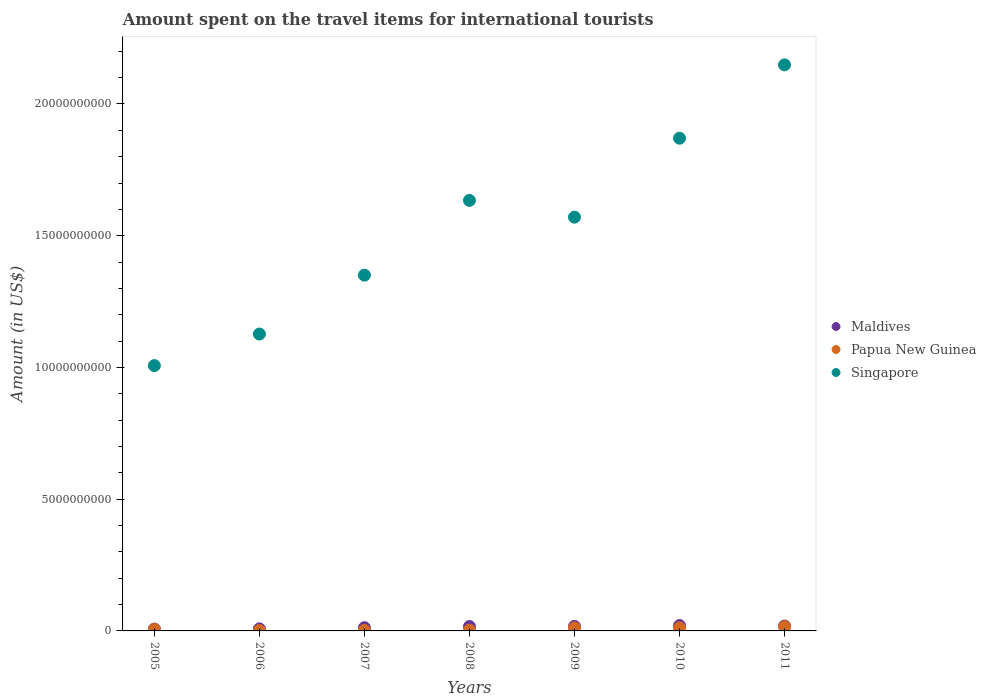How many different coloured dotlines are there?
Provide a succinct answer. 3. What is the amount spent on the travel items for international tourists in Singapore in 2008?
Give a very brief answer. 1.63e+1. Across all years, what is the maximum amount spent on the travel items for international tourists in Singapore?
Keep it short and to the point. 2.15e+1. Across all years, what is the minimum amount spent on the travel items for international tourists in Maldives?
Give a very brief answer. 7.00e+07. In which year was the amount spent on the travel items for international tourists in Singapore maximum?
Provide a short and direct response. 2011. What is the total amount spent on the travel items for international tourists in Singapore in the graph?
Make the answer very short. 1.07e+11. What is the difference between the amount spent on the travel items for international tourists in Papua New Guinea in 2008 and that in 2009?
Provide a short and direct response. -8.40e+07. What is the difference between the amount spent on the travel items for international tourists in Maldives in 2005 and the amount spent on the travel items for international tourists in Singapore in 2008?
Provide a succinct answer. -1.63e+1. What is the average amount spent on the travel items for international tourists in Papua New Guinea per year?
Ensure brevity in your answer.  7.36e+07. In the year 2005, what is the difference between the amount spent on the travel items for international tourists in Singapore and amount spent on the travel items for international tourists in Maldives?
Offer a very short reply. 1.00e+1. What is the ratio of the amount spent on the travel items for international tourists in Singapore in 2008 to that in 2009?
Make the answer very short. 1.04. What is the difference between the highest and the second highest amount spent on the travel items for international tourists in Papua New Guinea?
Offer a very short reply. 4.20e+07. What is the difference between the highest and the lowest amount spent on the travel items for international tourists in Maldives?
Offer a very short reply. 1.35e+08. In how many years, is the amount spent on the travel items for international tourists in Papua New Guinea greater than the average amount spent on the travel items for international tourists in Papua New Guinea taken over all years?
Keep it short and to the point. 3. Is it the case that in every year, the sum of the amount spent on the travel items for international tourists in Singapore and amount spent on the travel items for international tourists in Maldives  is greater than the amount spent on the travel items for international tourists in Papua New Guinea?
Your response must be concise. Yes. How many dotlines are there?
Your answer should be very brief. 3. How many years are there in the graph?
Your response must be concise. 7. What is the difference between two consecutive major ticks on the Y-axis?
Ensure brevity in your answer.  5.00e+09. Does the graph contain any zero values?
Your answer should be very brief. No. How many legend labels are there?
Your answer should be very brief. 3. What is the title of the graph?
Offer a very short reply. Amount spent on the travel items for international tourists. Does "Zimbabwe" appear as one of the legend labels in the graph?
Your response must be concise. No. What is the label or title of the Y-axis?
Your answer should be very brief. Amount (in US$). What is the Amount (in US$) in Maldives in 2005?
Keep it short and to the point. 7.00e+07. What is the Amount (in US$) of Papua New Guinea in 2005?
Give a very brief answer. 5.60e+07. What is the Amount (in US$) of Singapore in 2005?
Offer a very short reply. 1.01e+1. What is the Amount (in US$) in Maldives in 2006?
Provide a succinct answer. 7.80e+07. What is the Amount (in US$) in Papua New Guinea in 2006?
Give a very brief answer. 1.60e+07. What is the Amount (in US$) of Singapore in 2006?
Ensure brevity in your answer.  1.13e+1. What is the Amount (in US$) of Maldives in 2007?
Your response must be concise. 1.22e+08. What is the Amount (in US$) of Papua New Guinea in 2007?
Give a very brief answer. 2.10e+07. What is the Amount (in US$) of Singapore in 2007?
Keep it short and to the point. 1.35e+1. What is the Amount (in US$) of Maldives in 2008?
Provide a succinct answer. 1.67e+08. What is the Amount (in US$) in Papua New Guinea in 2008?
Your response must be concise. 2.90e+07. What is the Amount (in US$) in Singapore in 2008?
Provide a succinct answer. 1.63e+1. What is the Amount (in US$) in Maldives in 2009?
Make the answer very short. 1.74e+08. What is the Amount (in US$) of Papua New Guinea in 2009?
Offer a very short reply. 1.13e+08. What is the Amount (in US$) in Singapore in 2009?
Provide a short and direct response. 1.57e+1. What is the Amount (in US$) of Maldives in 2010?
Ensure brevity in your answer.  2.05e+08. What is the Amount (in US$) in Papua New Guinea in 2010?
Provide a succinct answer. 1.19e+08. What is the Amount (in US$) in Singapore in 2010?
Your answer should be compact. 1.87e+1. What is the Amount (in US$) of Maldives in 2011?
Provide a short and direct response. 1.86e+08. What is the Amount (in US$) in Papua New Guinea in 2011?
Provide a succinct answer. 1.61e+08. What is the Amount (in US$) of Singapore in 2011?
Offer a terse response. 2.15e+1. Across all years, what is the maximum Amount (in US$) of Maldives?
Your response must be concise. 2.05e+08. Across all years, what is the maximum Amount (in US$) in Papua New Guinea?
Your answer should be very brief. 1.61e+08. Across all years, what is the maximum Amount (in US$) of Singapore?
Offer a very short reply. 2.15e+1. Across all years, what is the minimum Amount (in US$) of Maldives?
Your response must be concise. 7.00e+07. Across all years, what is the minimum Amount (in US$) in Papua New Guinea?
Provide a short and direct response. 1.60e+07. Across all years, what is the minimum Amount (in US$) of Singapore?
Your answer should be very brief. 1.01e+1. What is the total Amount (in US$) of Maldives in the graph?
Provide a short and direct response. 1.00e+09. What is the total Amount (in US$) of Papua New Guinea in the graph?
Your response must be concise. 5.15e+08. What is the total Amount (in US$) of Singapore in the graph?
Give a very brief answer. 1.07e+11. What is the difference between the Amount (in US$) in Maldives in 2005 and that in 2006?
Keep it short and to the point. -8.00e+06. What is the difference between the Amount (in US$) in Papua New Guinea in 2005 and that in 2006?
Offer a very short reply. 4.00e+07. What is the difference between the Amount (in US$) of Singapore in 2005 and that in 2006?
Offer a very short reply. -1.20e+09. What is the difference between the Amount (in US$) of Maldives in 2005 and that in 2007?
Make the answer very short. -5.20e+07. What is the difference between the Amount (in US$) of Papua New Guinea in 2005 and that in 2007?
Your response must be concise. 3.50e+07. What is the difference between the Amount (in US$) of Singapore in 2005 and that in 2007?
Your response must be concise. -3.43e+09. What is the difference between the Amount (in US$) of Maldives in 2005 and that in 2008?
Offer a terse response. -9.70e+07. What is the difference between the Amount (in US$) in Papua New Guinea in 2005 and that in 2008?
Provide a short and direct response. 2.70e+07. What is the difference between the Amount (in US$) of Singapore in 2005 and that in 2008?
Ensure brevity in your answer.  -6.27e+09. What is the difference between the Amount (in US$) of Maldives in 2005 and that in 2009?
Offer a very short reply. -1.04e+08. What is the difference between the Amount (in US$) in Papua New Guinea in 2005 and that in 2009?
Ensure brevity in your answer.  -5.70e+07. What is the difference between the Amount (in US$) of Singapore in 2005 and that in 2009?
Your answer should be compact. -5.63e+09. What is the difference between the Amount (in US$) in Maldives in 2005 and that in 2010?
Give a very brief answer. -1.35e+08. What is the difference between the Amount (in US$) of Papua New Guinea in 2005 and that in 2010?
Give a very brief answer. -6.30e+07. What is the difference between the Amount (in US$) of Singapore in 2005 and that in 2010?
Make the answer very short. -8.63e+09. What is the difference between the Amount (in US$) in Maldives in 2005 and that in 2011?
Make the answer very short. -1.16e+08. What is the difference between the Amount (in US$) in Papua New Guinea in 2005 and that in 2011?
Provide a succinct answer. -1.05e+08. What is the difference between the Amount (in US$) of Singapore in 2005 and that in 2011?
Give a very brief answer. -1.14e+1. What is the difference between the Amount (in US$) in Maldives in 2006 and that in 2007?
Give a very brief answer. -4.40e+07. What is the difference between the Amount (in US$) of Papua New Guinea in 2006 and that in 2007?
Provide a short and direct response. -5.00e+06. What is the difference between the Amount (in US$) in Singapore in 2006 and that in 2007?
Provide a short and direct response. -2.24e+09. What is the difference between the Amount (in US$) of Maldives in 2006 and that in 2008?
Offer a terse response. -8.90e+07. What is the difference between the Amount (in US$) of Papua New Guinea in 2006 and that in 2008?
Give a very brief answer. -1.30e+07. What is the difference between the Amount (in US$) in Singapore in 2006 and that in 2008?
Keep it short and to the point. -5.07e+09. What is the difference between the Amount (in US$) in Maldives in 2006 and that in 2009?
Ensure brevity in your answer.  -9.60e+07. What is the difference between the Amount (in US$) in Papua New Guinea in 2006 and that in 2009?
Provide a succinct answer. -9.70e+07. What is the difference between the Amount (in US$) of Singapore in 2006 and that in 2009?
Keep it short and to the point. -4.44e+09. What is the difference between the Amount (in US$) of Maldives in 2006 and that in 2010?
Your answer should be compact. -1.27e+08. What is the difference between the Amount (in US$) in Papua New Guinea in 2006 and that in 2010?
Give a very brief answer. -1.03e+08. What is the difference between the Amount (in US$) of Singapore in 2006 and that in 2010?
Make the answer very short. -7.43e+09. What is the difference between the Amount (in US$) of Maldives in 2006 and that in 2011?
Give a very brief answer. -1.08e+08. What is the difference between the Amount (in US$) of Papua New Guinea in 2006 and that in 2011?
Your answer should be very brief. -1.45e+08. What is the difference between the Amount (in US$) of Singapore in 2006 and that in 2011?
Your response must be concise. -1.02e+1. What is the difference between the Amount (in US$) in Maldives in 2007 and that in 2008?
Give a very brief answer. -4.50e+07. What is the difference between the Amount (in US$) of Papua New Guinea in 2007 and that in 2008?
Your answer should be very brief. -8.00e+06. What is the difference between the Amount (in US$) of Singapore in 2007 and that in 2008?
Provide a succinct answer. -2.84e+09. What is the difference between the Amount (in US$) of Maldives in 2007 and that in 2009?
Offer a very short reply. -5.20e+07. What is the difference between the Amount (in US$) in Papua New Guinea in 2007 and that in 2009?
Give a very brief answer. -9.20e+07. What is the difference between the Amount (in US$) of Singapore in 2007 and that in 2009?
Your answer should be very brief. -2.20e+09. What is the difference between the Amount (in US$) of Maldives in 2007 and that in 2010?
Offer a very short reply. -8.30e+07. What is the difference between the Amount (in US$) in Papua New Guinea in 2007 and that in 2010?
Offer a very short reply. -9.80e+07. What is the difference between the Amount (in US$) in Singapore in 2007 and that in 2010?
Your answer should be compact. -5.20e+09. What is the difference between the Amount (in US$) in Maldives in 2007 and that in 2011?
Your answer should be very brief. -6.40e+07. What is the difference between the Amount (in US$) of Papua New Guinea in 2007 and that in 2011?
Give a very brief answer. -1.40e+08. What is the difference between the Amount (in US$) of Singapore in 2007 and that in 2011?
Offer a very short reply. -7.98e+09. What is the difference between the Amount (in US$) in Maldives in 2008 and that in 2009?
Keep it short and to the point. -7.00e+06. What is the difference between the Amount (in US$) in Papua New Guinea in 2008 and that in 2009?
Offer a very short reply. -8.40e+07. What is the difference between the Amount (in US$) in Singapore in 2008 and that in 2009?
Offer a terse response. 6.36e+08. What is the difference between the Amount (in US$) of Maldives in 2008 and that in 2010?
Make the answer very short. -3.80e+07. What is the difference between the Amount (in US$) in Papua New Guinea in 2008 and that in 2010?
Your answer should be compact. -9.00e+07. What is the difference between the Amount (in US$) in Singapore in 2008 and that in 2010?
Your answer should be compact. -2.36e+09. What is the difference between the Amount (in US$) of Maldives in 2008 and that in 2011?
Your answer should be very brief. -1.90e+07. What is the difference between the Amount (in US$) in Papua New Guinea in 2008 and that in 2011?
Offer a terse response. -1.32e+08. What is the difference between the Amount (in US$) in Singapore in 2008 and that in 2011?
Offer a very short reply. -5.14e+09. What is the difference between the Amount (in US$) in Maldives in 2009 and that in 2010?
Provide a succinct answer. -3.10e+07. What is the difference between the Amount (in US$) of Papua New Guinea in 2009 and that in 2010?
Your answer should be compact. -6.00e+06. What is the difference between the Amount (in US$) of Singapore in 2009 and that in 2010?
Offer a very short reply. -3.00e+09. What is the difference between the Amount (in US$) in Maldives in 2009 and that in 2011?
Offer a terse response. -1.20e+07. What is the difference between the Amount (in US$) of Papua New Guinea in 2009 and that in 2011?
Your answer should be compact. -4.80e+07. What is the difference between the Amount (in US$) of Singapore in 2009 and that in 2011?
Keep it short and to the point. -5.78e+09. What is the difference between the Amount (in US$) of Maldives in 2010 and that in 2011?
Your answer should be compact. 1.90e+07. What is the difference between the Amount (in US$) of Papua New Guinea in 2010 and that in 2011?
Your response must be concise. -4.20e+07. What is the difference between the Amount (in US$) in Singapore in 2010 and that in 2011?
Your response must be concise. -2.78e+09. What is the difference between the Amount (in US$) of Maldives in 2005 and the Amount (in US$) of Papua New Guinea in 2006?
Your answer should be very brief. 5.40e+07. What is the difference between the Amount (in US$) in Maldives in 2005 and the Amount (in US$) in Singapore in 2006?
Provide a short and direct response. -1.12e+1. What is the difference between the Amount (in US$) in Papua New Guinea in 2005 and the Amount (in US$) in Singapore in 2006?
Make the answer very short. -1.12e+1. What is the difference between the Amount (in US$) of Maldives in 2005 and the Amount (in US$) of Papua New Guinea in 2007?
Offer a terse response. 4.90e+07. What is the difference between the Amount (in US$) in Maldives in 2005 and the Amount (in US$) in Singapore in 2007?
Keep it short and to the point. -1.34e+1. What is the difference between the Amount (in US$) of Papua New Guinea in 2005 and the Amount (in US$) of Singapore in 2007?
Ensure brevity in your answer.  -1.34e+1. What is the difference between the Amount (in US$) in Maldives in 2005 and the Amount (in US$) in Papua New Guinea in 2008?
Provide a short and direct response. 4.10e+07. What is the difference between the Amount (in US$) of Maldives in 2005 and the Amount (in US$) of Singapore in 2008?
Give a very brief answer. -1.63e+1. What is the difference between the Amount (in US$) of Papua New Guinea in 2005 and the Amount (in US$) of Singapore in 2008?
Your answer should be very brief. -1.63e+1. What is the difference between the Amount (in US$) of Maldives in 2005 and the Amount (in US$) of Papua New Guinea in 2009?
Keep it short and to the point. -4.30e+07. What is the difference between the Amount (in US$) in Maldives in 2005 and the Amount (in US$) in Singapore in 2009?
Give a very brief answer. -1.56e+1. What is the difference between the Amount (in US$) in Papua New Guinea in 2005 and the Amount (in US$) in Singapore in 2009?
Give a very brief answer. -1.56e+1. What is the difference between the Amount (in US$) of Maldives in 2005 and the Amount (in US$) of Papua New Guinea in 2010?
Provide a short and direct response. -4.90e+07. What is the difference between the Amount (in US$) of Maldives in 2005 and the Amount (in US$) of Singapore in 2010?
Provide a short and direct response. -1.86e+1. What is the difference between the Amount (in US$) in Papua New Guinea in 2005 and the Amount (in US$) in Singapore in 2010?
Your answer should be compact. -1.86e+1. What is the difference between the Amount (in US$) in Maldives in 2005 and the Amount (in US$) in Papua New Guinea in 2011?
Your answer should be compact. -9.10e+07. What is the difference between the Amount (in US$) of Maldives in 2005 and the Amount (in US$) of Singapore in 2011?
Make the answer very short. -2.14e+1. What is the difference between the Amount (in US$) of Papua New Guinea in 2005 and the Amount (in US$) of Singapore in 2011?
Your answer should be very brief. -2.14e+1. What is the difference between the Amount (in US$) in Maldives in 2006 and the Amount (in US$) in Papua New Guinea in 2007?
Ensure brevity in your answer.  5.70e+07. What is the difference between the Amount (in US$) of Maldives in 2006 and the Amount (in US$) of Singapore in 2007?
Your answer should be very brief. -1.34e+1. What is the difference between the Amount (in US$) of Papua New Guinea in 2006 and the Amount (in US$) of Singapore in 2007?
Your answer should be very brief. -1.35e+1. What is the difference between the Amount (in US$) of Maldives in 2006 and the Amount (in US$) of Papua New Guinea in 2008?
Your answer should be very brief. 4.90e+07. What is the difference between the Amount (in US$) of Maldives in 2006 and the Amount (in US$) of Singapore in 2008?
Keep it short and to the point. -1.63e+1. What is the difference between the Amount (in US$) of Papua New Guinea in 2006 and the Amount (in US$) of Singapore in 2008?
Your answer should be compact. -1.63e+1. What is the difference between the Amount (in US$) of Maldives in 2006 and the Amount (in US$) of Papua New Guinea in 2009?
Offer a very short reply. -3.50e+07. What is the difference between the Amount (in US$) in Maldives in 2006 and the Amount (in US$) in Singapore in 2009?
Your response must be concise. -1.56e+1. What is the difference between the Amount (in US$) in Papua New Guinea in 2006 and the Amount (in US$) in Singapore in 2009?
Make the answer very short. -1.57e+1. What is the difference between the Amount (in US$) in Maldives in 2006 and the Amount (in US$) in Papua New Guinea in 2010?
Provide a succinct answer. -4.10e+07. What is the difference between the Amount (in US$) in Maldives in 2006 and the Amount (in US$) in Singapore in 2010?
Your answer should be compact. -1.86e+1. What is the difference between the Amount (in US$) in Papua New Guinea in 2006 and the Amount (in US$) in Singapore in 2010?
Give a very brief answer. -1.87e+1. What is the difference between the Amount (in US$) of Maldives in 2006 and the Amount (in US$) of Papua New Guinea in 2011?
Your answer should be compact. -8.30e+07. What is the difference between the Amount (in US$) in Maldives in 2006 and the Amount (in US$) in Singapore in 2011?
Provide a short and direct response. -2.14e+1. What is the difference between the Amount (in US$) of Papua New Guinea in 2006 and the Amount (in US$) of Singapore in 2011?
Give a very brief answer. -2.15e+1. What is the difference between the Amount (in US$) of Maldives in 2007 and the Amount (in US$) of Papua New Guinea in 2008?
Make the answer very short. 9.30e+07. What is the difference between the Amount (in US$) of Maldives in 2007 and the Amount (in US$) of Singapore in 2008?
Make the answer very short. -1.62e+1. What is the difference between the Amount (in US$) in Papua New Guinea in 2007 and the Amount (in US$) in Singapore in 2008?
Your answer should be very brief. -1.63e+1. What is the difference between the Amount (in US$) in Maldives in 2007 and the Amount (in US$) in Papua New Guinea in 2009?
Provide a succinct answer. 9.00e+06. What is the difference between the Amount (in US$) in Maldives in 2007 and the Amount (in US$) in Singapore in 2009?
Provide a succinct answer. -1.56e+1. What is the difference between the Amount (in US$) of Papua New Guinea in 2007 and the Amount (in US$) of Singapore in 2009?
Make the answer very short. -1.57e+1. What is the difference between the Amount (in US$) of Maldives in 2007 and the Amount (in US$) of Papua New Guinea in 2010?
Offer a terse response. 3.00e+06. What is the difference between the Amount (in US$) in Maldives in 2007 and the Amount (in US$) in Singapore in 2010?
Offer a terse response. -1.86e+1. What is the difference between the Amount (in US$) in Papua New Guinea in 2007 and the Amount (in US$) in Singapore in 2010?
Your response must be concise. -1.87e+1. What is the difference between the Amount (in US$) in Maldives in 2007 and the Amount (in US$) in Papua New Guinea in 2011?
Offer a terse response. -3.90e+07. What is the difference between the Amount (in US$) in Maldives in 2007 and the Amount (in US$) in Singapore in 2011?
Offer a very short reply. -2.14e+1. What is the difference between the Amount (in US$) of Papua New Guinea in 2007 and the Amount (in US$) of Singapore in 2011?
Keep it short and to the point. -2.15e+1. What is the difference between the Amount (in US$) in Maldives in 2008 and the Amount (in US$) in Papua New Guinea in 2009?
Provide a short and direct response. 5.40e+07. What is the difference between the Amount (in US$) in Maldives in 2008 and the Amount (in US$) in Singapore in 2009?
Make the answer very short. -1.55e+1. What is the difference between the Amount (in US$) of Papua New Guinea in 2008 and the Amount (in US$) of Singapore in 2009?
Keep it short and to the point. -1.57e+1. What is the difference between the Amount (in US$) in Maldives in 2008 and the Amount (in US$) in Papua New Guinea in 2010?
Offer a terse response. 4.80e+07. What is the difference between the Amount (in US$) of Maldives in 2008 and the Amount (in US$) of Singapore in 2010?
Your answer should be very brief. -1.85e+1. What is the difference between the Amount (in US$) of Papua New Guinea in 2008 and the Amount (in US$) of Singapore in 2010?
Your response must be concise. -1.87e+1. What is the difference between the Amount (in US$) of Maldives in 2008 and the Amount (in US$) of Papua New Guinea in 2011?
Give a very brief answer. 6.00e+06. What is the difference between the Amount (in US$) of Maldives in 2008 and the Amount (in US$) of Singapore in 2011?
Keep it short and to the point. -2.13e+1. What is the difference between the Amount (in US$) of Papua New Guinea in 2008 and the Amount (in US$) of Singapore in 2011?
Ensure brevity in your answer.  -2.15e+1. What is the difference between the Amount (in US$) in Maldives in 2009 and the Amount (in US$) in Papua New Guinea in 2010?
Keep it short and to the point. 5.50e+07. What is the difference between the Amount (in US$) of Maldives in 2009 and the Amount (in US$) of Singapore in 2010?
Provide a succinct answer. -1.85e+1. What is the difference between the Amount (in US$) in Papua New Guinea in 2009 and the Amount (in US$) in Singapore in 2010?
Ensure brevity in your answer.  -1.86e+1. What is the difference between the Amount (in US$) in Maldives in 2009 and the Amount (in US$) in Papua New Guinea in 2011?
Provide a succinct answer. 1.30e+07. What is the difference between the Amount (in US$) in Maldives in 2009 and the Amount (in US$) in Singapore in 2011?
Your answer should be compact. -2.13e+1. What is the difference between the Amount (in US$) of Papua New Guinea in 2009 and the Amount (in US$) of Singapore in 2011?
Keep it short and to the point. -2.14e+1. What is the difference between the Amount (in US$) of Maldives in 2010 and the Amount (in US$) of Papua New Guinea in 2011?
Give a very brief answer. 4.40e+07. What is the difference between the Amount (in US$) of Maldives in 2010 and the Amount (in US$) of Singapore in 2011?
Provide a succinct answer. -2.13e+1. What is the difference between the Amount (in US$) in Papua New Guinea in 2010 and the Amount (in US$) in Singapore in 2011?
Offer a very short reply. -2.14e+1. What is the average Amount (in US$) in Maldives per year?
Your answer should be compact. 1.43e+08. What is the average Amount (in US$) in Papua New Guinea per year?
Provide a short and direct response. 7.36e+07. What is the average Amount (in US$) of Singapore per year?
Your answer should be compact. 1.53e+1. In the year 2005, what is the difference between the Amount (in US$) of Maldives and Amount (in US$) of Papua New Guinea?
Your answer should be very brief. 1.40e+07. In the year 2005, what is the difference between the Amount (in US$) of Maldives and Amount (in US$) of Singapore?
Offer a terse response. -1.00e+1. In the year 2005, what is the difference between the Amount (in US$) in Papua New Guinea and Amount (in US$) in Singapore?
Give a very brief answer. -1.00e+1. In the year 2006, what is the difference between the Amount (in US$) of Maldives and Amount (in US$) of Papua New Guinea?
Keep it short and to the point. 6.20e+07. In the year 2006, what is the difference between the Amount (in US$) in Maldives and Amount (in US$) in Singapore?
Your response must be concise. -1.12e+1. In the year 2006, what is the difference between the Amount (in US$) in Papua New Guinea and Amount (in US$) in Singapore?
Make the answer very short. -1.13e+1. In the year 2007, what is the difference between the Amount (in US$) of Maldives and Amount (in US$) of Papua New Guinea?
Offer a terse response. 1.01e+08. In the year 2007, what is the difference between the Amount (in US$) in Maldives and Amount (in US$) in Singapore?
Offer a terse response. -1.34e+1. In the year 2007, what is the difference between the Amount (in US$) of Papua New Guinea and Amount (in US$) of Singapore?
Keep it short and to the point. -1.35e+1. In the year 2008, what is the difference between the Amount (in US$) of Maldives and Amount (in US$) of Papua New Guinea?
Offer a terse response. 1.38e+08. In the year 2008, what is the difference between the Amount (in US$) in Maldives and Amount (in US$) in Singapore?
Ensure brevity in your answer.  -1.62e+1. In the year 2008, what is the difference between the Amount (in US$) in Papua New Guinea and Amount (in US$) in Singapore?
Ensure brevity in your answer.  -1.63e+1. In the year 2009, what is the difference between the Amount (in US$) of Maldives and Amount (in US$) of Papua New Guinea?
Ensure brevity in your answer.  6.10e+07. In the year 2009, what is the difference between the Amount (in US$) of Maldives and Amount (in US$) of Singapore?
Your response must be concise. -1.55e+1. In the year 2009, what is the difference between the Amount (in US$) of Papua New Guinea and Amount (in US$) of Singapore?
Keep it short and to the point. -1.56e+1. In the year 2010, what is the difference between the Amount (in US$) of Maldives and Amount (in US$) of Papua New Guinea?
Keep it short and to the point. 8.60e+07. In the year 2010, what is the difference between the Amount (in US$) in Maldives and Amount (in US$) in Singapore?
Keep it short and to the point. -1.85e+1. In the year 2010, what is the difference between the Amount (in US$) of Papua New Guinea and Amount (in US$) of Singapore?
Your answer should be compact. -1.86e+1. In the year 2011, what is the difference between the Amount (in US$) of Maldives and Amount (in US$) of Papua New Guinea?
Offer a terse response. 2.50e+07. In the year 2011, what is the difference between the Amount (in US$) of Maldives and Amount (in US$) of Singapore?
Your answer should be compact. -2.13e+1. In the year 2011, what is the difference between the Amount (in US$) of Papua New Guinea and Amount (in US$) of Singapore?
Provide a short and direct response. -2.13e+1. What is the ratio of the Amount (in US$) in Maldives in 2005 to that in 2006?
Make the answer very short. 0.9. What is the ratio of the Amount (in US$) of Singapore in 2005 to that in 2006?
Offer a terse response. 0.89. What is the ratio of the Amount (in US$) in Maldives in 2005 to that in 2007?
Keep it short and to the point. 0.57. What is the ratio of the Amount (in US$) of Papua New Guinea in 2005 to that in 2007?
Provide a short and direct response. 2.67. What is the ratio of the Amount (in US$) in Singapore in 2005 to that in 2007?
Give a very brief answer. 0.75. What is the ratio of the Amount (in US$) of Maldives in 2005 to that in 2008?
Give a very brief answer. 0.42. What is the ratio of the Amount (in US$) of Papua New Guinea in 2005 to that in 2008?
Give a very brief answer. 1.93. What is the ratio of the Amount (in US$) in Singapore in 2005 to that in 2008?
Your answer should be compact. 0.62. What is the ratio of the Amount (in US$) of Maldives in 2005 to that in 2009?
Offer a very short reply. 0.4. What is the ratio of the Amount (in US$) of Papua New Guinea in 2005 to that in 2009?
Keep it short and to the point. 0.5. What is the ratio of the Amount (in US$) in Singapore in 2005 to that in 2009?
Offer a terse response. 0.64. What is the ratio of the Amount (in US$) of Maldives in 2005 to that in 2010?
Your response must be concise. 0.34. What is the ratio of the Amount (in US$) in Papua New Guinea in 2005 to that in 2010?
Offer a terse response. 0.47. What is the ratio of the Amount (in US$) of Singapore in 2005 to that in 2010?
Provide a succinct answer. 0.54. What is the ratio of the Amount (in US$) in Maldives in 2005 to that in 2011?
Provide a short and direct response. 0.38. What is the ratio of the Amount (in US$) of Papua New Guinea in 2005 to that in 2011?
Your answer should be compact. 0.35. What is the ratio of the Amount (in US$) of Singapore in 2005 to that in 2011?
Your response must be concise. 0.47. What is the ratio of the Amount (in US$) in Maldives in 2006 to that in 2007?
Offer a very short reply. 0.64. What is the ratio of the Amount (in US$) in Papua New Guinea in 2006 to that in 2007?
Your answer should be very brief. 0.76. What is the ratio of the Amount (in US$) of Singapore in 2006 to that in 2007?
Your answer should be very brief. 0.83. What is the ratio of the Amount (in US$) of Maldives in 2006 to that in 2008?
Your answer should be compact. 0.47. What is the ratio of the Amount (in US$) in Papua New Guinea in 2006 to that in 2008?
Provide a succinct answer. 0.55. What is the ratio of the Amount (in US$) of Singapore in 2006 to that in 2008?
Provide a succinct answer. 0.69. What is the ratio of the Amount (in US$) of Maldives in 2006 to that in 2009?
Your response must be concise. 0.45. What is the ratio of the Amount (in US$) in Papua New Guinea in 2006 to that in 2009?
Make the answer very short. 0.14. What is the ratio of the Amount (in US$) in Singapore in 2006 to that in 2009?
Your answer should be very brief. 0.72. What is the ratio of the Amount (in US$) of Maldives in 2006 to that in 2010?
Offer a very short reply. 0.38. What is the ratio of the Amount (in US$) of Papua New Guinea in 2006 to that in 2010?
Make the answer very short. 0.13. What is the ratio of the Amount (in US$) in Singapore in 2006 to that in 2010?
Provide a short and direct response. 0.6. What is the ratio of the Amount (in US$) in Maldives in 2006 to that in 2011?
Give a very brief answer. 0.42. What is the ratio of the Amount (in US$) of Papua New Guinea in 2006 to that in 2011?
Provide a succinct answer. 0.1. What is the ratio of the Amount (in US$) of Singapore in 2006 to that in 2011?
Make the answer very short. 0.52. What is the ratio of the Amount (in US$) in Maldives in 2007 to that in 2008?
Your response must be concise. 0.73. What is the ratio of the Amount (in US$) in Papua New Guinea in 2007 to that in 2008?
Your answer should be very brief. 0.72. What is the ratio of the Amount (in US$) of Singapore in 2007 to that in 2008?
Provide a succinct answer. 0.83. What is the ratio of the Amount (in US$) in Maldives in 2007 to that in 2009?
Your response must be concise. 0.7. What is the ratio of the Amount (in US$) in Papua New Guinea in 2007 to that in 2009?
Your answer should be compact. 0.19. What is the ratio of the Amount (in US$) in Singapore in 2007 to that in 2009?
Offer a terse response. 0.86. What is the ratio of the Amount (in US$) in Maldives in 2007 to that in 2010?
Provide a short and direct response. 0.6. What is the ratio of the Amount (in US$) in Papua New Guinea in 2007 to that in 2010?
Give a very brief answer. 0.18. What is the ratio of the Amount (in US$) in Singapore in 2007 to that in 2010?
Make the answer very short. 0.72. What is the ratio of the Amount (in US$) of Maldives in 2007 to that in 2011?
Make the answer very short. 0.66. What is the ratio of the Amount (in US$) of Papua New Guinea in 2007 to that in 2011?
Keep it short and to the point. 0.13. What is the ratio of the Amount (in US$) of Singapore in 2007 to that in 2011?
Offer a very short reply. 0.63. What is the ratio of the Amount (in US$) of Maldives in 2008 to that in 2009?
Make the answer very short. 0.96. What is the ratio of the Amount (in US$) of Papua New Guinea in 2008 to that in 2009?
Make the answer very short. 0.26. What is the ratio of the Amount (in US$) of Singapore in 2008 to that in 2009?
Make the answer very short. 1.04. What is the ratio of the Amount (in US$) in Maldives in 2008 to that in 2010?
Offer a terse response. 0.81. What is the ratio of the Amount (in US$) in Papua New Guinea in 2008 to that in 2010?
Provide a short and direct response. 0.24. What is the ratio of the Amount (in US$) of Singapore in 2008 to that in 2010?
Keep it short and to the point. 0.87. What is the ratio of the Amount (in US$) of Maldives in 2008 to that in 2011?
Your answer should be very brief. 0.9. What is the ratio of the Amount (in US$) of Papua New Guinea in 2008 to that in 2011?
Ensure brevity in your answer.  0.18. What is the ratio of the Amount (in US$) of Singapore in 2008 to that in 2011?
Your answer should be very brief. 0.76. What is the ratio of the Amount (in US$) in Maldives in 2009 to that in 2010?
Your response must be concise. 0.85. What is the ratio of the Amount (in US$) in Papua New Guinea in 2009 to that in 2010?
Offer a terse response. 0.95. What is the ratio of the Amount (in US$) of Singapore in 2009 to that in 2010?
Your response must be concise. 0.84. What is the ratio of the Amount (in US$) in Maldives in 2009 to that in 2011?
Ensure brevity in your answer.  0.94. What is the ratio of the Amount (in US$) of Papua New Guinea in 2009 to that in 2011?
Give a very brief answer. 0.7. What is the ratio of the Amount (in US$) of Singapore in 2009 to that in 2011?
Provide a succinct answer. 0.73. What is the ratio of the Amount (in US$) in Maldives in 2010 to that in 2011?
Keep it short and to the point. 1.1. What is the ratio of the Amount (in US$) of Papua New Guinea in 2010 to that in 2011?
Your answer should be very brief. 0.74. What is the ratio of the Amount (in US$) in Singapore in 2010 to that in 2011?
Offer a terse response. 0.87. What is the difference between the highest and the second highest Amount (in US$) in Maldives?
Make the answer very short. 1.90e+07. What is the difference between the highest and the second highest Amount (in US$) in Papua New Guinea?
Offer a very short reply. 4.20e+07. What is the difference between the highest and the second highest Amount (in US$) in Singapore?
Make the answer very short. 2.78e+09. What is the difference between the highest and the lowest Amount (in US$) in Maldives?
Offer a very short reply. 1.35e+08. What is the difference between the highest and the lowest Amount (in US$) in Papua New Guinea?
Your response must be concise. 1.45e+08. What is the difference between the highest and the lowest Amount (in US$) in Singapore?
Make the answer very short. 1.14e+1. 